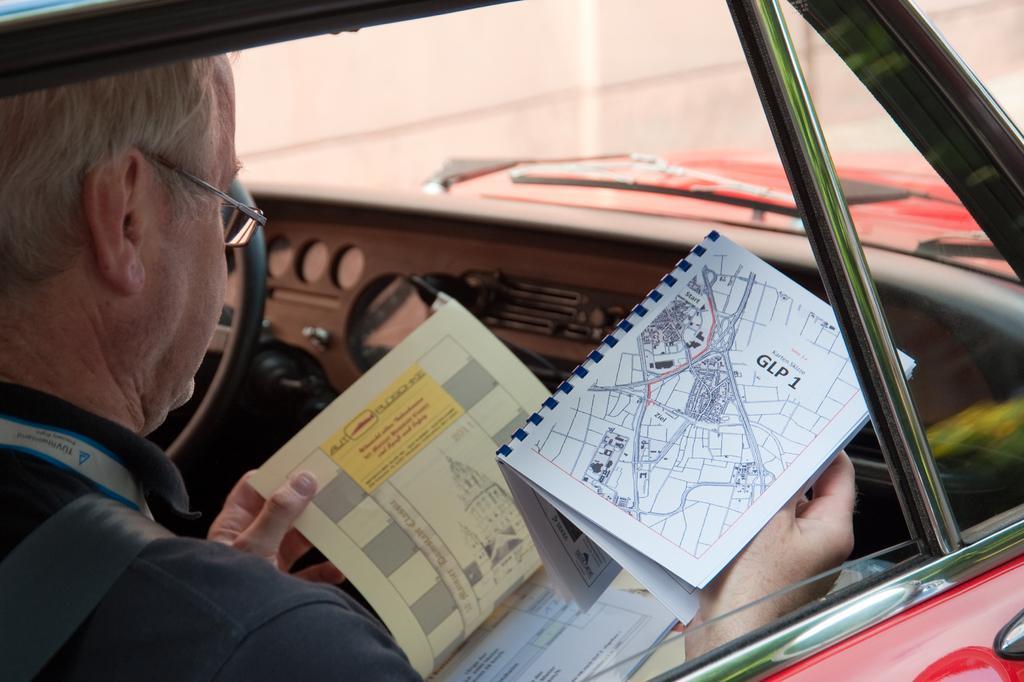In one or two sentences, can you explain what this image depicts? In this image we can see a man sitting inside a vehicle and he is holding books. Through the windscreen we can see a wall. 